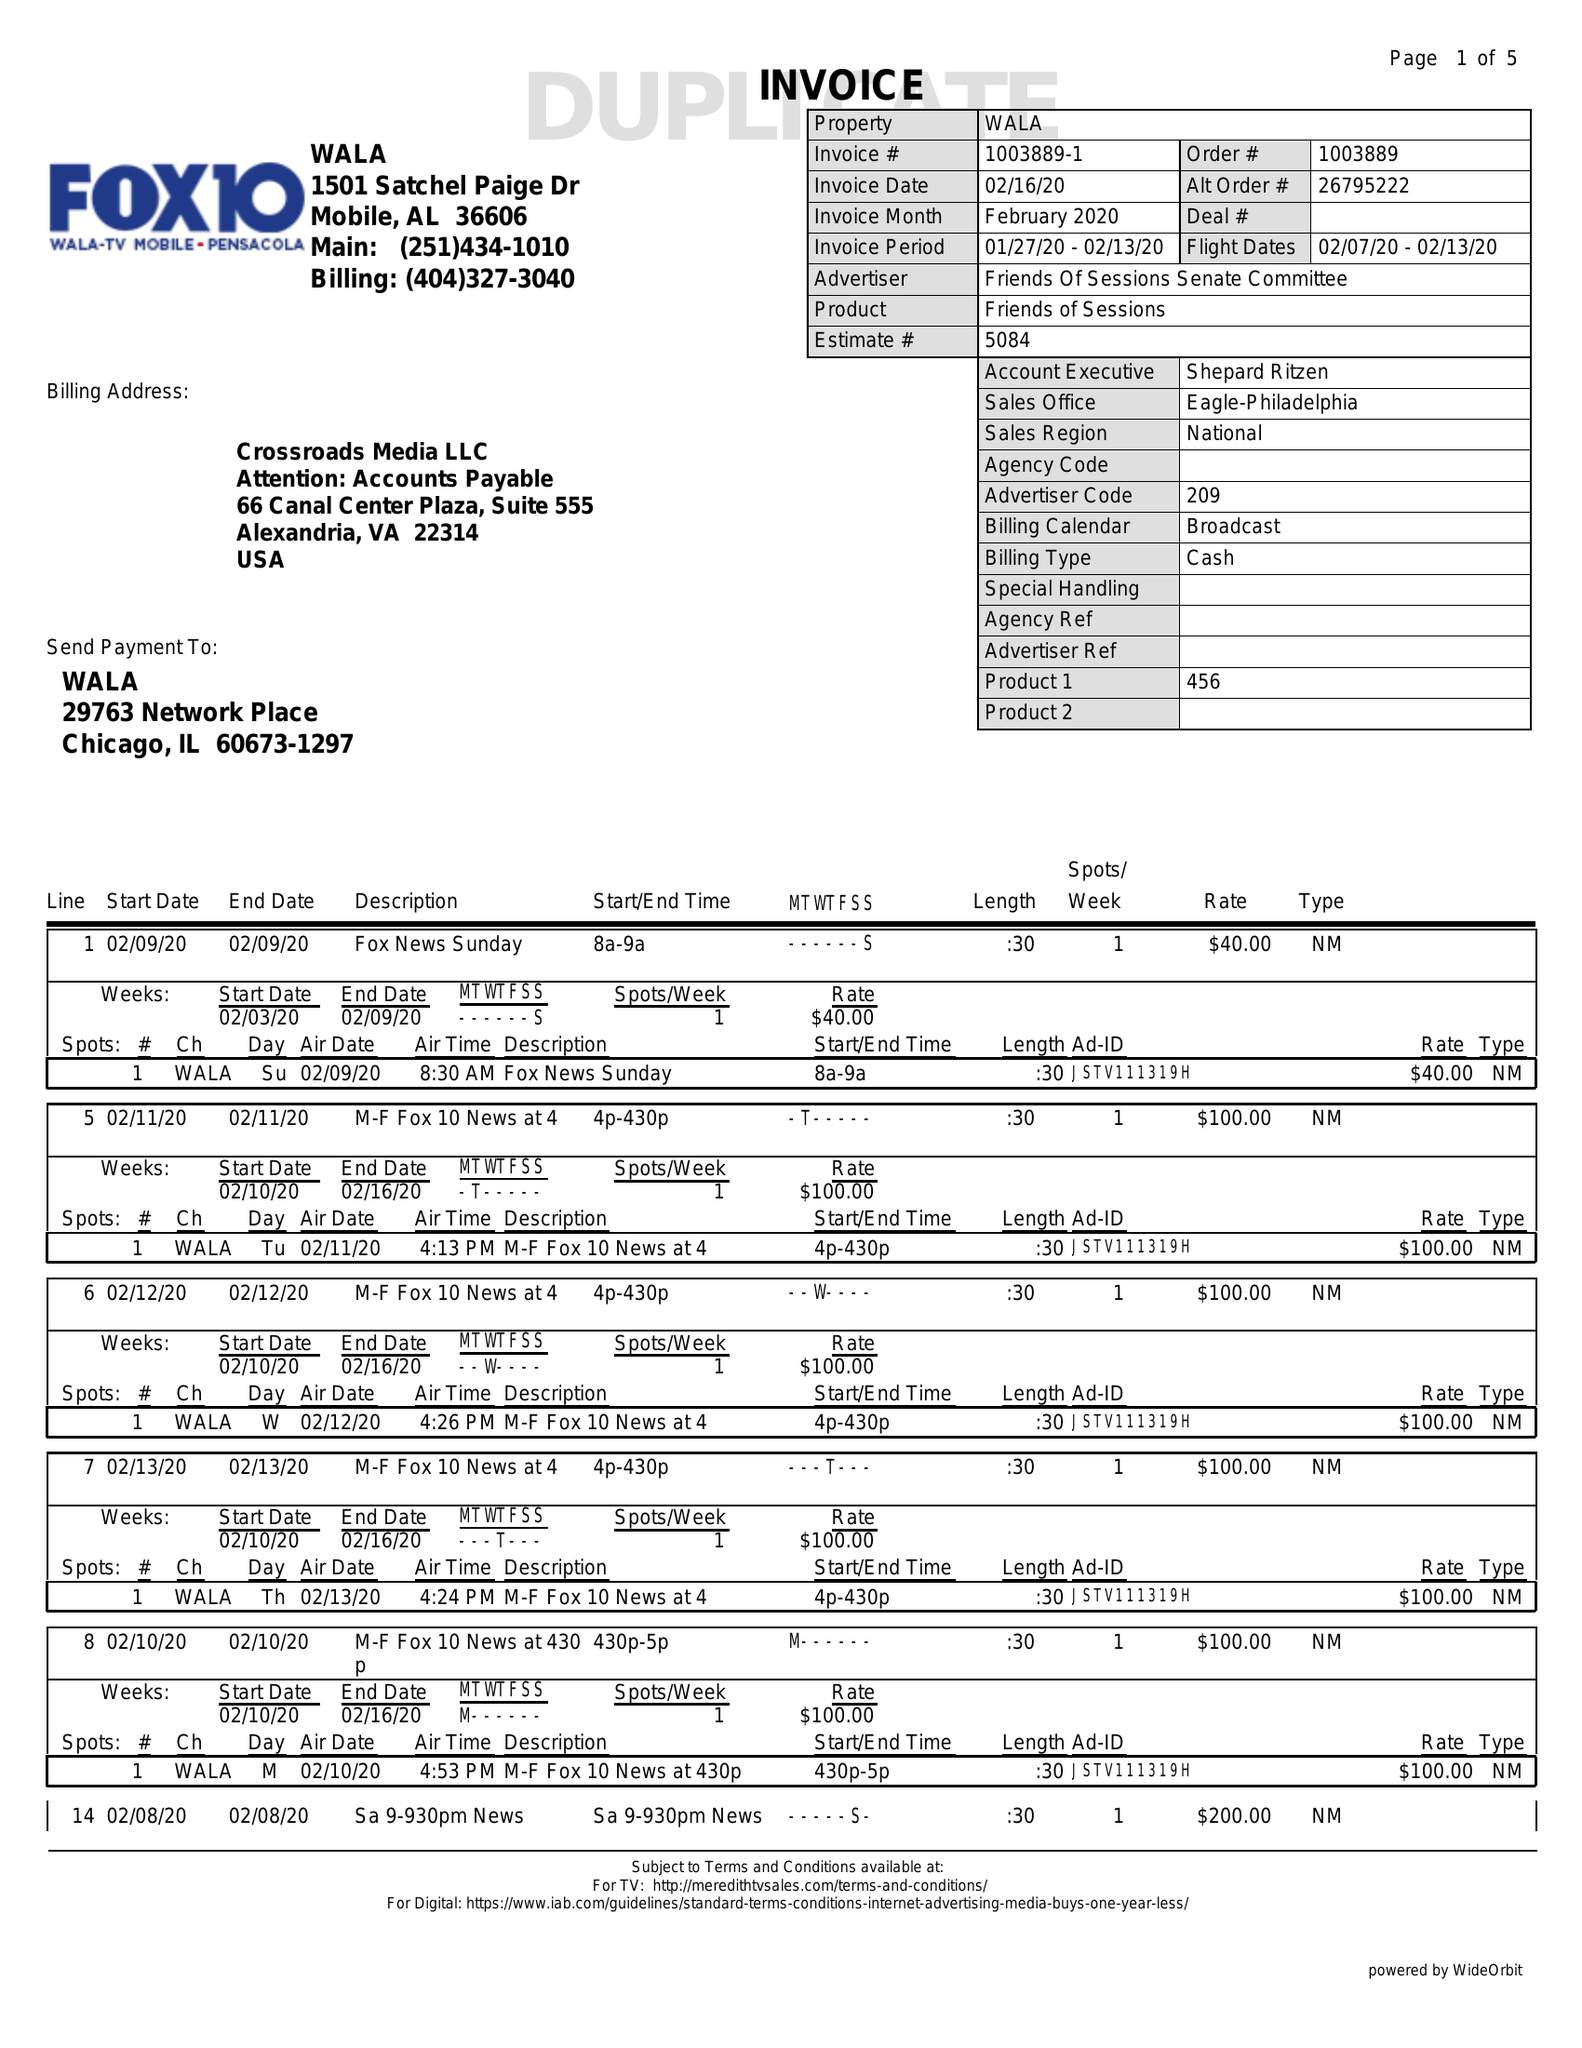What is the value for the flight_from?
Answer the question using a single word or phrase. 02/07/20 